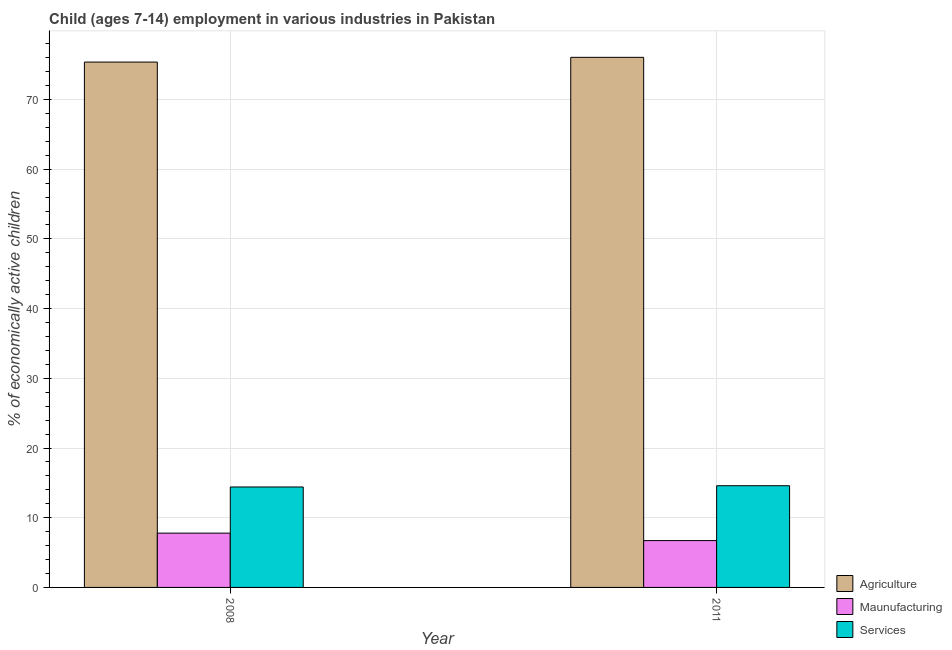How many different coloured bars are there?
Provide a short and direct response. 3. How many groups of bars are there?
Provide a succinct answer. 2. Are the number of bars on each tick of the X-axis equal?
Ensure brevity in your answer.  Yes. How many bars are there on the 1st tick from the left?
Provide a short and direct response. 3. How many bars are there on the 2nd tick from the right?
Make the answer very short. 3. What is the percentage of economically active children in services in 2008?
Your answer should be compact. 14.41. Across all years, what is the maximum percentage of economically active children in services?
Give a very brief answer. 14.59. Across all years, what is the minimum percentage of economically active children in manufacturing?
Provide a short and direct response. 6.72. In which year was the percentage of economically active children in services maximum?
Your answer should be compact. 2011. What is the total percentage of economically active children in agriculture in the graph?
Keep it short and to the point. 151.42. What is the difference between the percentage of economically active children in manufacturing in 2008 and that in 2011?
Keep it short and to the point. 1.07. What is the difference between the percentage of economically active children in services in 2011 and the percentage of economically active children in agriculture in 2008?
Provide a short and direct response. 0.18. What is the average percentage of economically active children in agriculture per year?
Offer a terse response. 75.71. In the year 2011, what is the difference between the percentage of economically active children in manufacturing and percentage of economically active children in services?
Keep it short and to the point. 0. In how many years, is the percentage of economically active children in manufacturing greater than 34 %?
Offer a very short reply. 0. What is the ratio of the percentage of economically active children in services in 2008 to that in 2011?
Provide a short and direct response. 0.99. What does the 1st bar from the left in 2011 represents?
Your answer should be compact. Agriculture. What does the 3rd bar from the right in 2008 represents?
Provide a succinct answer. Agriculture. Are all the bars in the graph horizontal?
Offer a terse response. No. What is the difference between two consecutive major ticks on the Y-axis?
Your answer should be compact. 10. Does the graph contain any zero values?
Your response must be concise. No. Does the graph contain grids?
Your response must be concise. Yes. Where does the legend appear in the graph?
Make the answer very short. Bottom right. How are the legend labels stacked?
Provide a succinct answer. Vertical. What is the title of the graph?
Offer a terse response. Child (ages 7-14) employment in various industries in Pakistan. Does "Injury" appear as one of the legend labels in the graph?
Offer a very short reply. No. What is the label or title of the X-axis?
Offer a very short reply. Year. What is the label or title of the Y-axis?
Provide a succinct answer. % of economically active children. What is the % of economically active children of Agriculture in 2008?
Provide a short and direct response. 75.37. What is the % of economically active children in Maunufacturing in 2008?
Make the answer very short. 7.79. What is the % of economically active children of Services in 2008?
Offer a terse response. 14.41. What is the % of economically active children of Agriculture in 2011?
Make the answer very short. 76.05. What is the % of economically active children in Maunufacturing in 2011?
Give a very brief answer. 6.72. What is the % of economically active children in Services in 2011?
Keep it short and to the point. 14.59. Across all years, what is the maximum % of economically active children in Agriculture?
Make the answer very short. 76.05. Across all years, what is the maximum % of economically active children in Maunufacturing?
Provide a succinct answer. 7.79. Across all years, what is the maximum % of economically active children of Services?
Your answer should be very brief. 14.59. Across all years, what is the minimum % of economically active children in Agriculture?
Your response must be concise. 75.37. Across all years, what is the minimum % of economically active children of Maunufacturing?
Keep it short and to the point. 6.72. Across all years, what is the minimum % of economically active children in Services?
Give a very brief answer. 14.41. What is the total % of economically active children in Agriculture in the graph?
Offer a terse response. 151.42. What is the total % of economically active children in Maunufacturing in the graph?
Your answer should be very brief. 14.51. What is the difference between the % of economically active children in Agriculture in 2008 and that in 2011?
Give a very brief answer. -0.68. What is the difference between the % of economically active children in Maunufacturing in 2008 and that in 2011?
Make the answer very short. 1.07. What is the difference between the % of economically active children of Services in 2008 and that in 2011?
Offer a very short reply. -0.18. What is the difference between the % of economically active children of Agriculture in 2008 and the % of economically active children of Maunufacturing in 2011?
Your answer should be compact. 68.65. What is the difference between the % of economically active children in Agriculture in 2008 and the % of economically active children in Services in 2011?
Provide a short and direct response. 60.78. What is the average % of economically active children of Agriculture per year?
Provide a succinct answer. 75.71. What is the average % of economically active children of Maunufacturing per year?
Your answer should be compact. 7.25. In the year 2008, what is the difference between the % of economically active children in Agriculture and % of economically active children in Maunufacturing?
Your response must be concise. 67.58. In the year 2008, what is the difference between the % of economically active children of Agriculture and % of economically active children of Services?
Ensure brevity in your answer.  60.96. In the year 2008, what is the difference between the % of economically active children in Maunufacturing and % of economically active children in Services?
Provide a short and direct response. -6.62. In the year 2011, what is the difference between the % of economically active children of Agriculture and % of economically active children of Maunufacturing?
Provide a short and direct response. 69.33. In the year 2011, what is the difference between the % of economically active children in Agriculture and % of economically active children in Services?
Make the answer very short. 61.46. In the year 2011, what is the difference between the % of economically active children in Maunufacturing and % of economically active children in Services?
Provide a short and direct response. -7.87. What is the ratio of the % of economically active children of Agriculture in 2008 to that in 2011?
Your response must be concise. 0.99. What is the ratio of the % of economically active children in Maunufacturing in 2008 to that in 2011?
Give a very brief answer. 1.16. What is the ratio of the % of economically active children in Services in 2008 to that in 2011?
Offer a terse response. 0.99. What is the difference between the highest and the second highest % of economically active children of Agriculture?
Provide a short and direct response. 0.68. What is the difference between the highest and the second highest % of economically active children of Maunufacturing?
Give a very brief answer. 1.07. What is the difference between the highest and the second highest % of economically active children in Services?
Your answer should be compact. 0.18. What is the difference between the highest and the lowest % of economically active children in Agriculture?
Ensure brevity in your answer.  0.68. What is the difference between the highest and the lowest % of economically active children of Maunufacturing?
Provide a succinct answer. 1.07. What is the difference between the highest and the lowest % of economically active children of Services?
Provide a succinct answer. 0.18. 